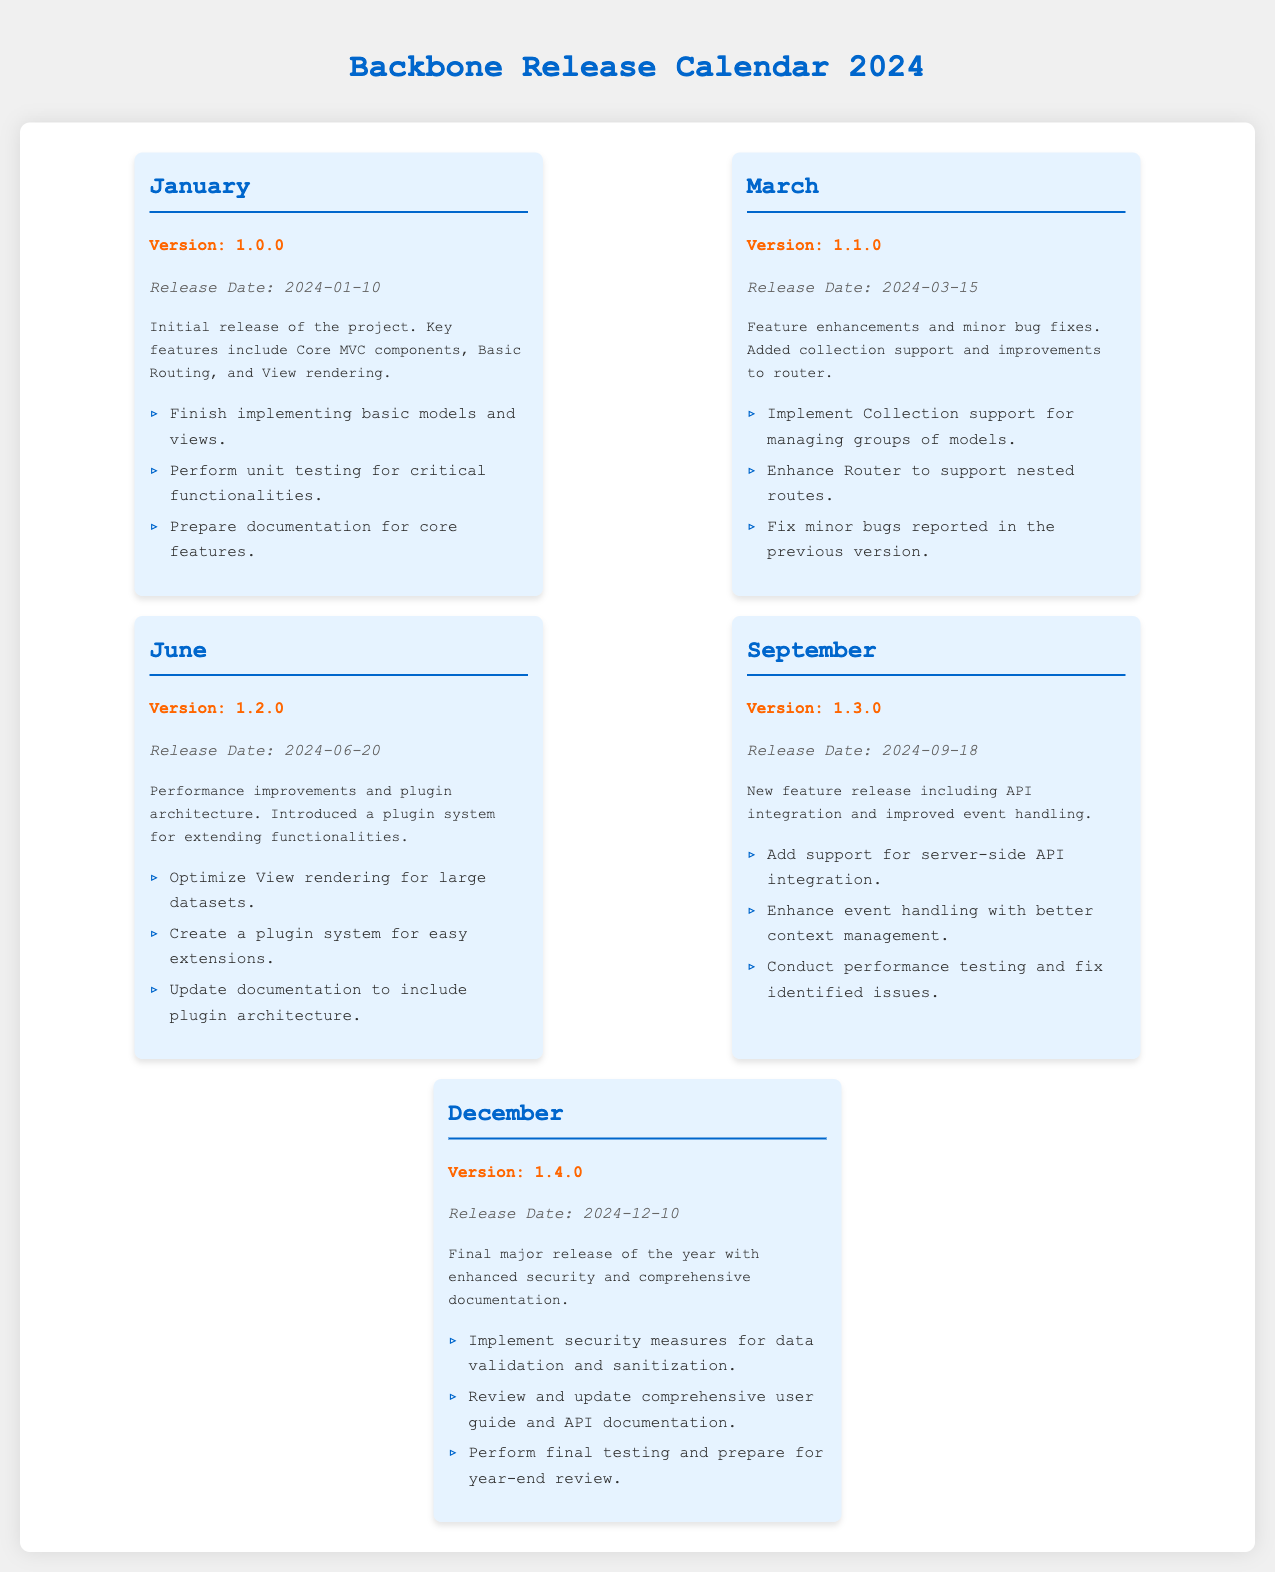What is the release date of Version 1.0.0? The release date for Version 1.0.0 is clearly stated in the document.
Answer: 2024-01-10 What major feature was introduced in Version 1.2.0? The document mentions that Version 1.2.0 introduced a plugin system, a significant feature.
Answer: Plugin system How many versions are scheduled for release in 2024? By counting the version sections in the document, we can determine the number of releases planned for the year.
Answer: 5 What month is Version 1.3.0 released? The month of release for Version 1.3.0 is specified in its section of the document.
Answer: September Which version includes performance improvements? The document lists details for each version, and Version 1.2.0 is noted for performance improvements.
Answer: 1.2.0 What tasks are planned for December before final testing? The tasks in the December section provide information regarding what activities are planned.
Answer: Implement security measures for data validation and sanitization Which version covers API integration? The document explicitly states that Version 1.3.0 includes support for server-side API integration.
Answer: 1.3.0 What is the color of the calendar background? The style of the document mentions the background color used in the calendar section.
Answer: White What is the primary focus of the January release? The details provided in the January section offer insight into the focus of this version.
Answer: Core MVC components 